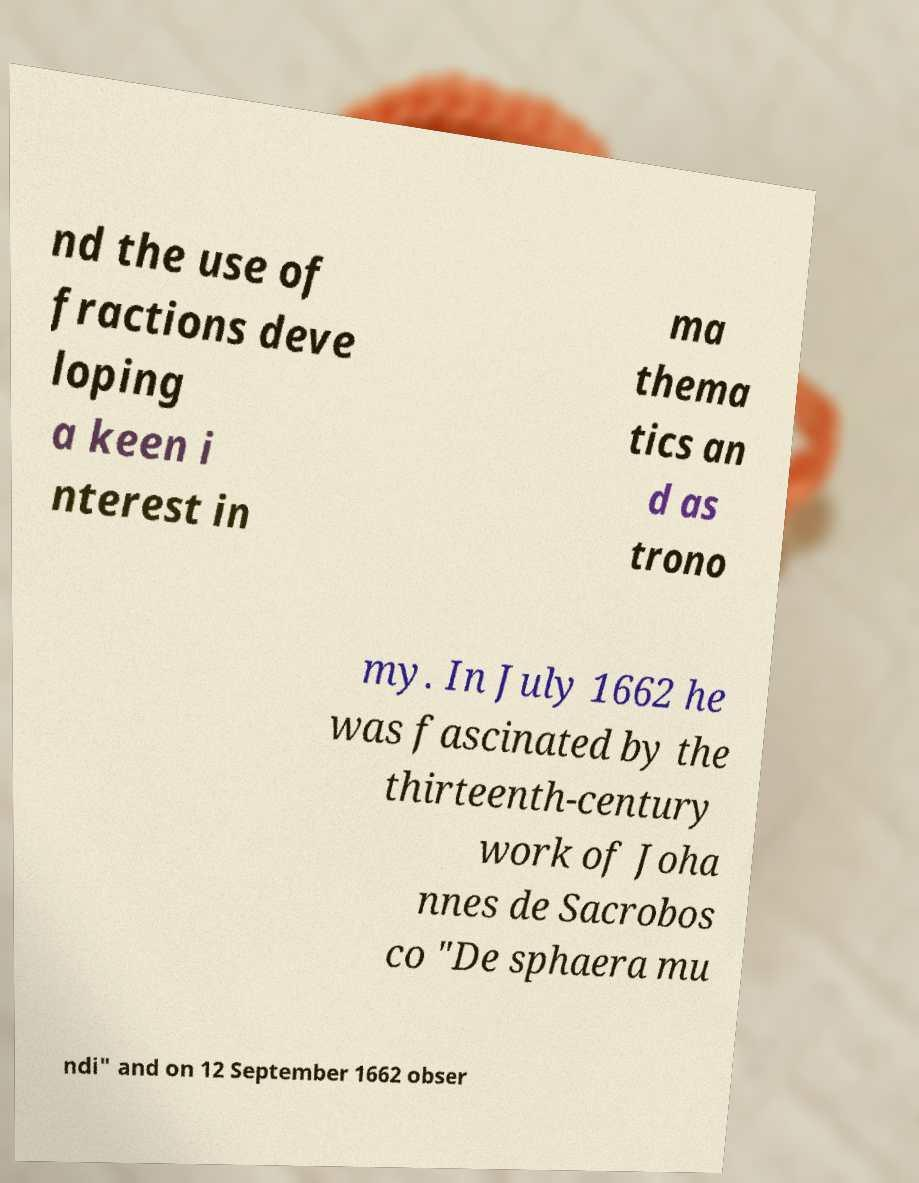I need the written content from this picture converted into text. Can you do that? nd the use of fractions deve loping a keen i nterest in ma thema tics an d as trono my. In July 1662 he was fascinated by the thirteenth-century work of Joha nnes de Sacrobos co "De sphaera mu ndi" and on 12 September 1662 obser 